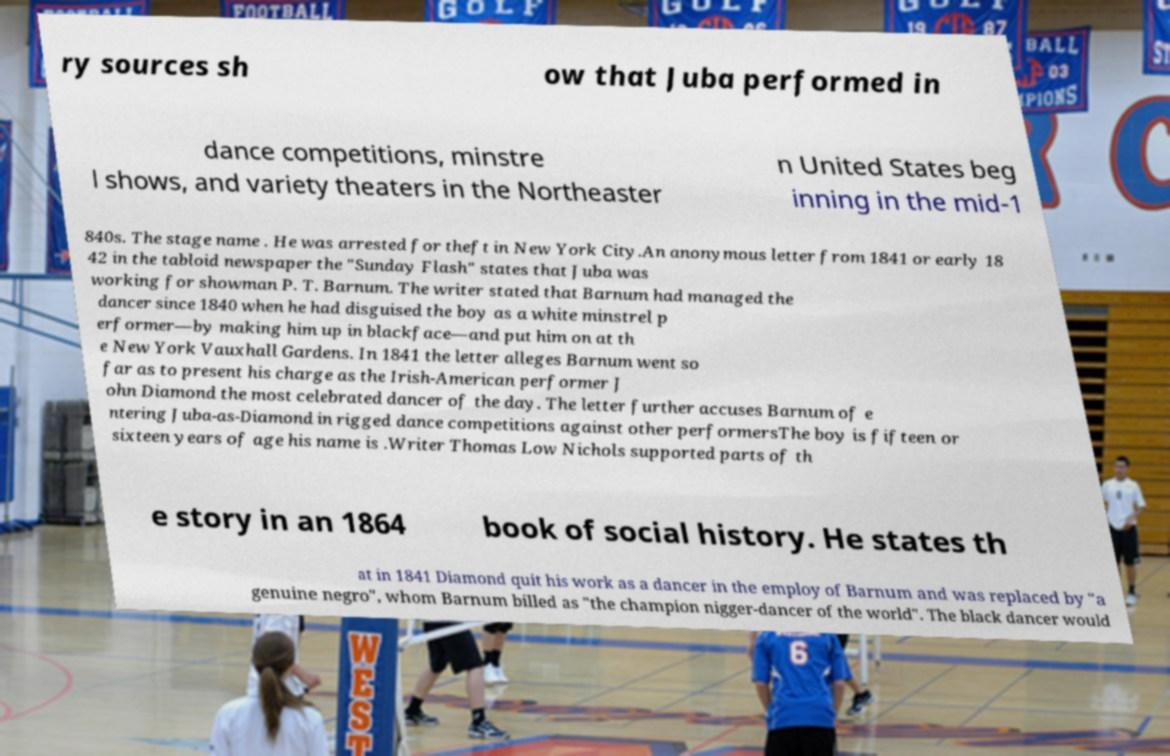Can you read and provide the text displayed in the image?This photo seems to have some interesting text. Can you extract and type it out for me? ry sources sh ow that Juba performed in dance competitions, minstre l shows, and variety theaters in the Northeaster n United States beg inning in the mid-1 840s. The stage name . He was arrested for theft in New York City.An anonymous letter from 1841 or early 18 42 in the tabloid newspaper the "Sunday Flash" states that Juba was working for showman P. T. Barnum. The writer stated that Barnum had managed the dancer since 1840 when he had disguised the boy as a white minstrel p erformer—by making him up in blackface—and put him on at th e New York Vauxhall Gardens. In 1841 the letter alleges Barnum went so far as to present his charge as the Irish-American performer J ohn Diamond the most celebrated dancer of the day. The letter further accuses Barnum of e ntering Juba-as-Diamond in rigged dance competitions against other performersThe boy is fifteen or sixteen years of age his name is .Writer Thomas Low Nichols supported parts of th e story in an 1864 book of social history. He states th at in 1841 Diamond quit his work as a dancer in the employ of Barnum and was replaced by "a genuine negro", whom Barnum billed as "the champion nigger-dancer of the world". The black dancer would 